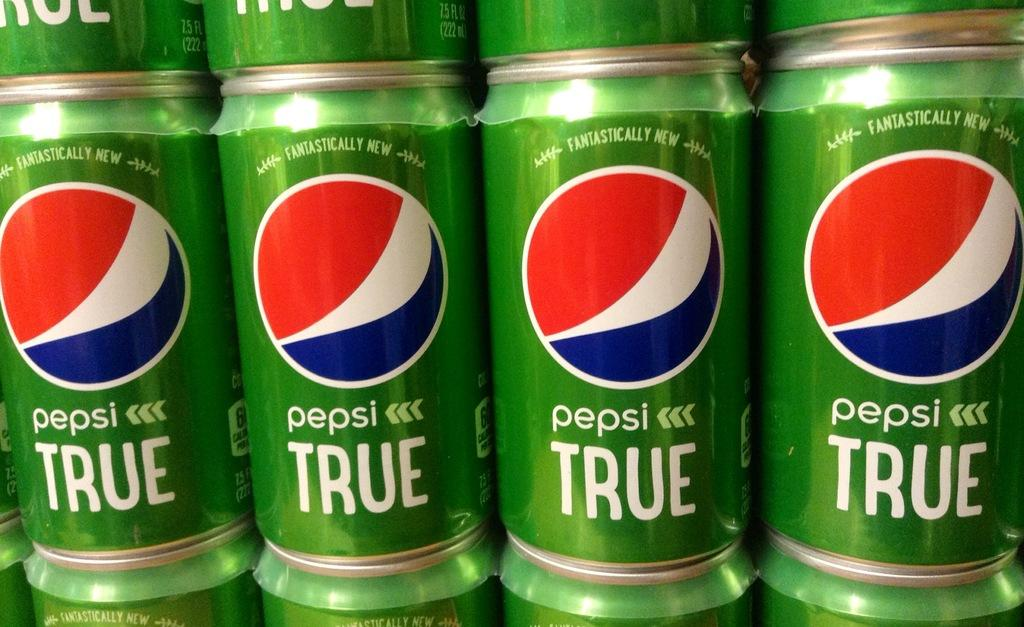<image>
Relay a brief, clear account of the picture shown. a pepsi can that is among many others 